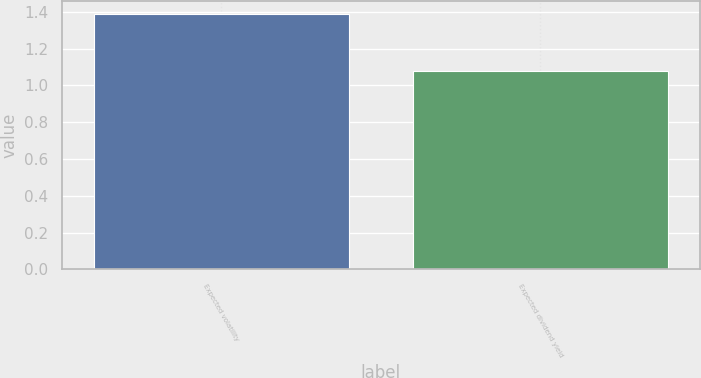Convert chart. <chart><loc_0><loc_0><loc_500><loc_500><bar_chart><fcel>Expected volatility<fcel>Expected dividend yield<nl><fcel>1.39<fcel>1.08<nl></chart> 